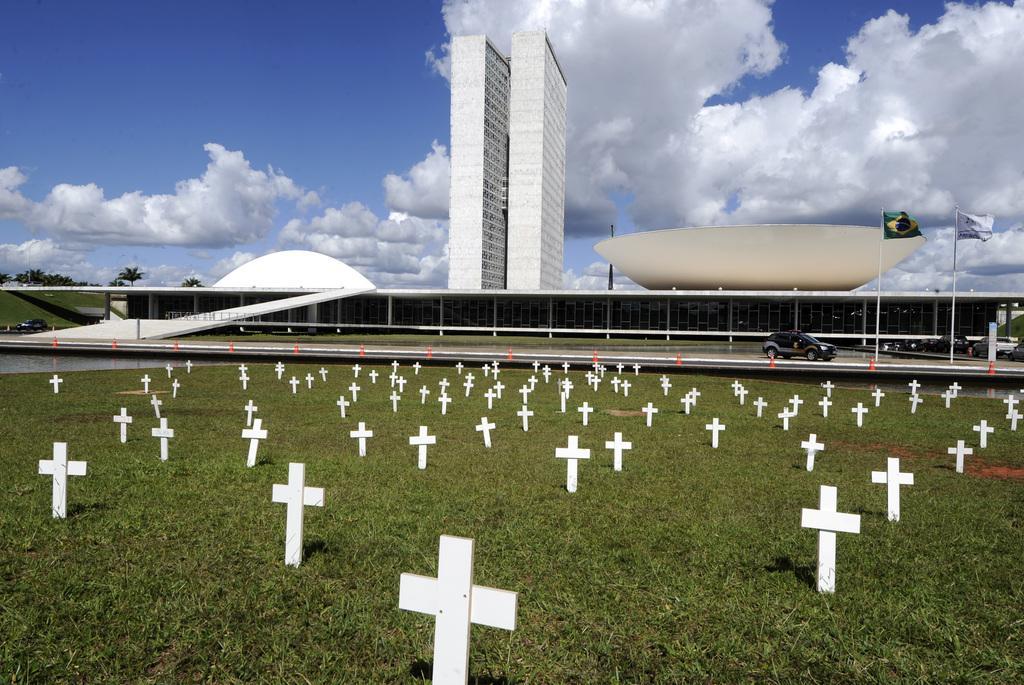Can you describe this image briefly? In this image we can see many cross symbols on the grass, we can see a vehicle on the road, flags to the pole, glass building, trees and the sky with clouds in the background. 